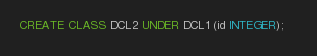<code> <loc_0><loc_0><loc_500><loc_500><_SQL_>CREATE CLASS DCL2 UNDER DCL1 (id INTEGER);	</code> 